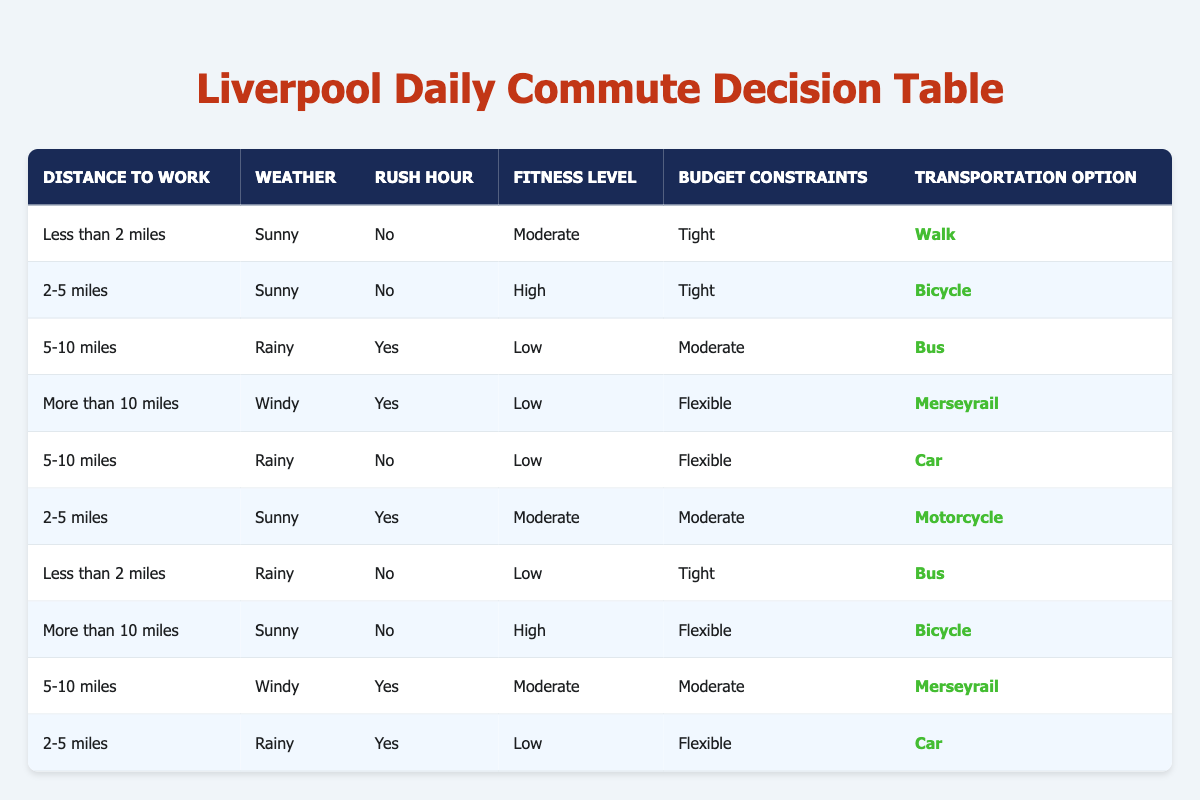What is the recommended transportation option for a distance of less than 2 miles on a sunny day with no rush hour? According to the table, when the distance is less than 2 miles, the weather is sunny, and there is no rush hour, the recommended action is to walk.
Answer: Walk In which weather condition should you take the bus if the commute distance is between 5 to 10 miles and it's rush hour? The table indicates that you should take the bus when the distance is 5-10 miles, it is rainy, and it is rush hour.
Answer: Rainy How many transportation options are available for a distance of more than 10 miles during a windy day? The table shows that for distances of more than 10 miles with windy weather, the options include just Merseyrail since all other conditions do not match any rows.
Answer: 1 Is it true that driving a car is recommended for a rainy day if the distance is between 2-5 miles and it is rush hour? Looking at the table, for a rainy day with a distance of 2-5 miles and rush hour, the recommended action is to drive a car, therefore it is true.
Answer: Yes What transportation option should be taken for a flexible budget and a distance of between 5 to 10 miles on a rainy day? The table specifies that for a distance of 5-10 miles on a rainy day and a flexible budget, the action to take is to drive a car.
Answer: Car What are the two transportation options available for distances of 2 to 5 miles during a sunny day? In the table, it is shown that for a distance of 2-5 miles on a sunny day, you can either bicycle when qualified conditions are met, or use a motorcycle if rush hour is also applicable. Thus, two options are available.
Answer: Bicycle, Motorcycle If there are 4 different weather conditions represented in the table, how many of them involve taking a motorcycle? The table indicates that there are 2 instances in which taking a motorcycle is the recommended transportation option. Hence, if we count based on the rows related to the motorcycle condition, the answer is 2.
Answer: 2 How does the recommendation for a tight budget differ between a distance of less than 2 miles and one of 5-10 miles on a rainy day? The data indicates that for a tight budget and a distance of less than 2 miles on a rainy day, the action is to take the bus, while for a distance of 5-10 miles, one should use the car. Thus, they differ by the modes of transportation recommended.
Answer: Bus, Car 